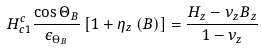Convert formula to latex. <formula><loc_0><loc_0><loc_500><loc_500>H _ { c 1 } ^ { c } \frac { \cos \Theta _ { B } } { \epsilon _ { \Theta _ { B } } } \left [ 1 + \eta _ { z } \left ( B \right ) \right ] = \frac { H _ { z } - \nu _ { z } B _ { z } } { 1 - \nu _ { z } }</formula> 